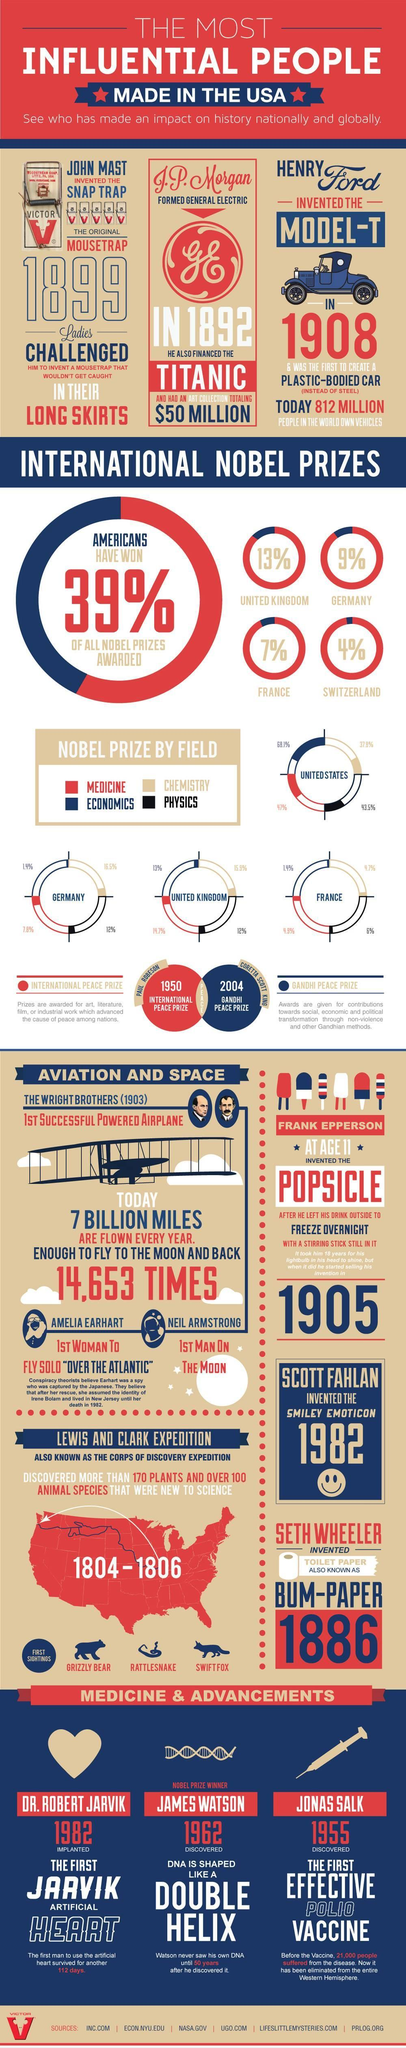What was the invention of John Mast?
Answer the question with a short phrase. Snap Trap In which year Henry Ford invented Model-T? 1908 In which year Lewis and Clark invented several flora and fauna species which was totally unknown to humankind? 1804-1806 Who Invented Model-T? Henry Ford In which year J.P Morgan gave financial support to the production of Titanic? 1892 In which field the most number of Nobel prizes have given? Economics Who invented the first successful powered flight? Wright brothers What percentage of Nobel Prize is won by the country France? 7% What percentage of Nobel Prize is won by the country Germany? 9% What is the inverse percentage of all Nobel prizes won by America? 61 